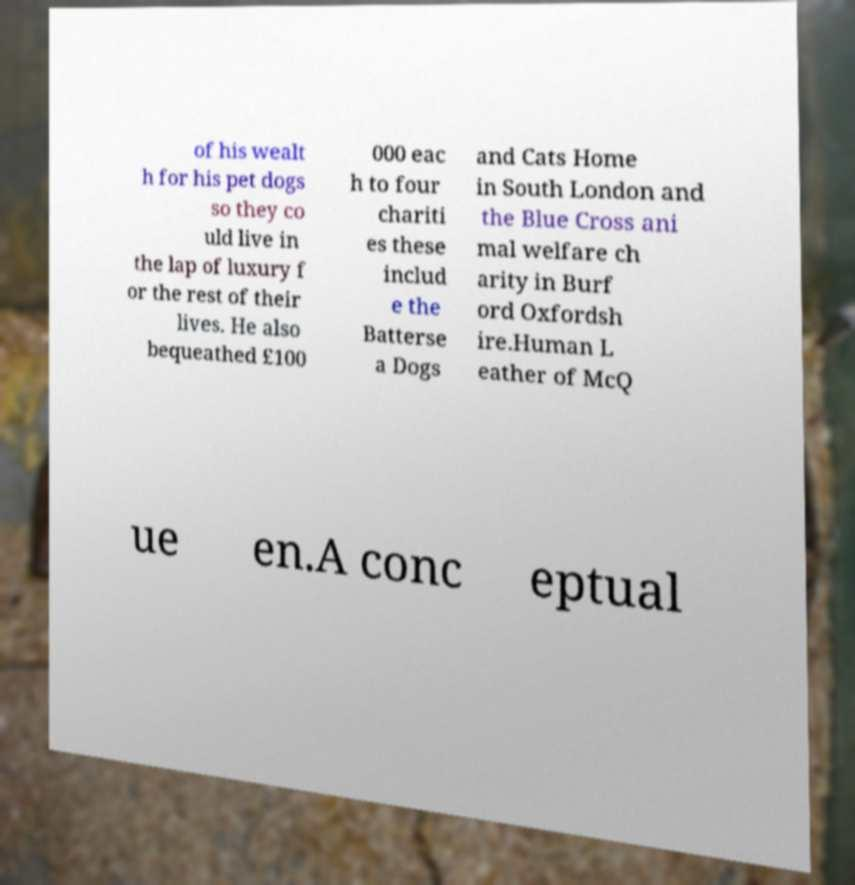Please read and relay the text visible in this image. What does it say? of his wealt h for his pet dogs so they co uld live in the lap of luxury f or the rest of their lives. He also bequeathed £100 000 eac h to four chariti es these includ e the Batterse a Dogs and Cats Home in South London and the Blue Cross ani mal welfare ch arity in Burf ord Oxfordsh ire.Human L eather of McQ ue en.A conc eptual 